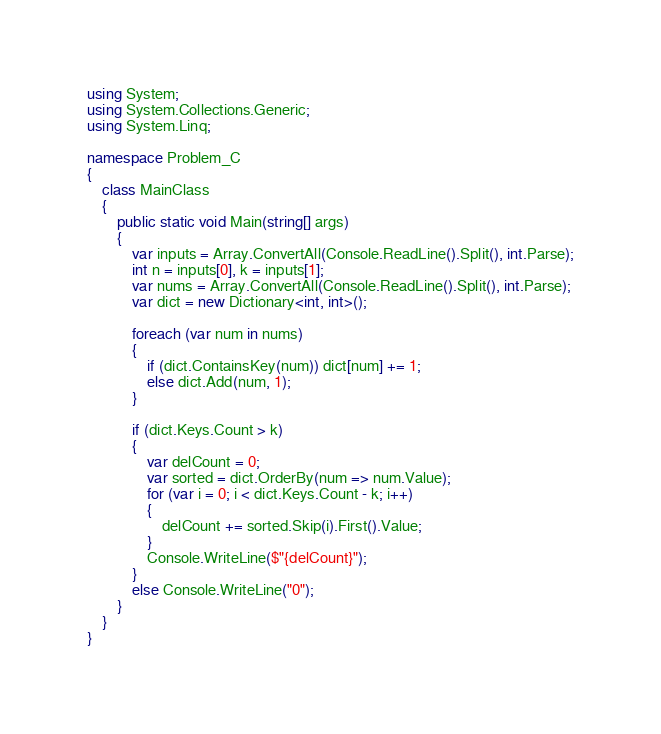Convert code to text. <code><loc_0><loc_0><loc_500><loc_500><_C#_>using System;
using System.Collections.Generic;
using System.Linq;

namespace Problem_C
{
    class MainClass
    {
        public static void Main(string[] args)
        {
            var inputs = Array.ConvertAll(Console.ReadLine().Split(), int.Parse);
            int n = inputs[0], k = inputs[1];
            var nums = Array.ConvertAll(Console.ReadLine().Split(), int.Parse);
            var dict = new Dictionary<int, int>();

            foreach (var num in nums)
            {
                if (dict.ContainsKey(num)) dict[num] += 1;
                else dict.Add(num, 1);
            }

            if (dict.Keys.Count > k)
            {
                var delCount = 0;
                var sorted = dict.OrderBy(num => num.Value);
                for (var i = 0; i < dict.Keys.Count - k; i++)
                {
                    delCount += sorted.Skip(i).First().Value;
                }
                Console.WriteLine($"{delCount}");
            }
            else Console.WriteLine("0");
        }
    }
}
</code> 